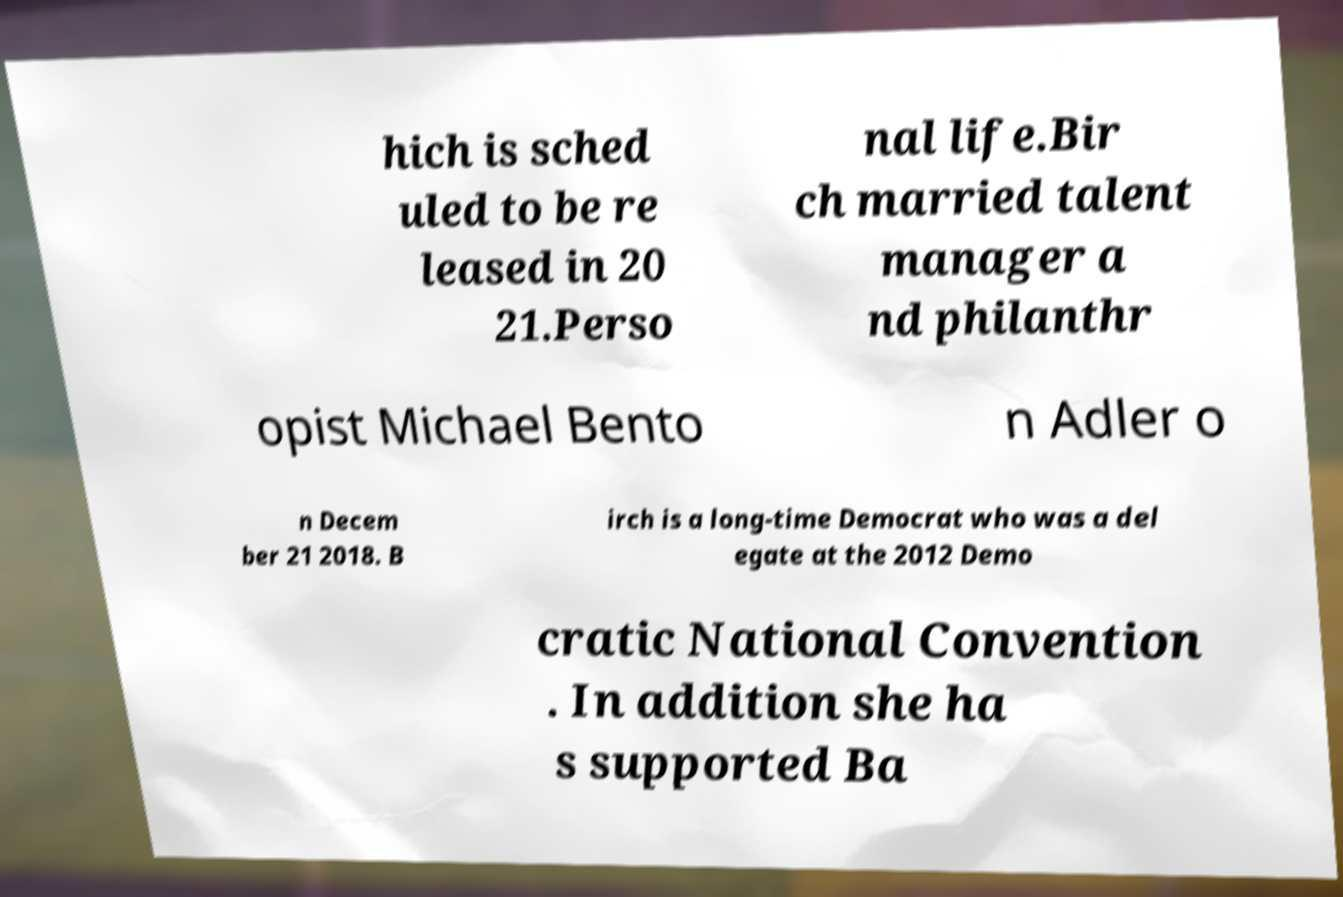Can you accurately transcribe the text from the provided image for me? hich is sched uled to be re leased in 20 21.Perso nal life.Bir ch married talent manager a nd philanthr opist Michael Bento n Adler o n Decem ber 21 2018. B irch is a long-time Democrat who was a del egate at the 2012 Demo cratic National Convention . In addition she ha s supported Ba 